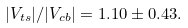Convert formula to latex. <formula><loc_0><loc_0><loc_500><loc_500>| V _ { t s } | / | V _ { c b } | = 1 . 1 0 \pm 0 . 4 3 .</formula> 